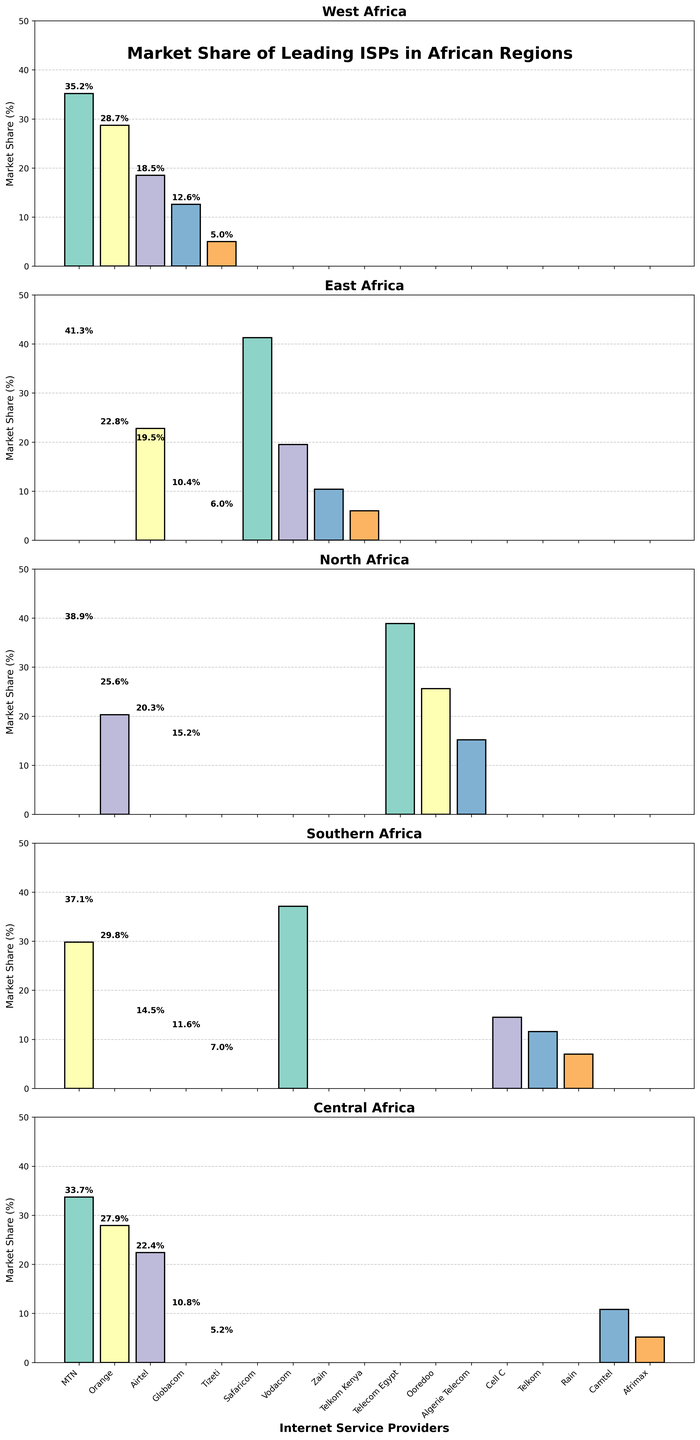Which ISP has the highest market share in West Africa? Look at the bar marked "MTN" in the West Africa section. It is the tallest with a 35.2% share.
Answer: MTN What is the combined market share of MTN and Orange in Central Africa? MTN has a 33.7% share and Orange has a 27.9% share. Adding them together: 33.7% + 27.9% = 61.6%.
Answer: 61.6% In which region does Airtel have the highest market share? Compare the bars for Airtel across all regions. Airtel has the tallest bar in East Africa with a 22.8% share.
Answer: East Africa How does Vodacom's market share in East Africa compare to its share in Southern Africa? Vodacom has a 19.5% share in East Africa and a 37.1% share in Southern Africa. The Southern Africa share is greater.
Answer: Southern Africa Which ISP has the lowest market share in North Africa? Look at the bars in the North Africa section. Algerie Telecom has the shortest bar with a 15.2% share.
Answer: Algerie Telecom What is the market share difference between MTN and Cell C in Southern Africa? MTN has a 29.8% share and Cell C has a 14.5% share. Subtract Cell C's share from MTN's: 29.8% - 14.5% = 15.3%.
Answer: 15.3% Compare the market share of Telkom in East Africa and Southern Africa. Telkom has a 6.0% share in East Africa and an 11.6% share in Southern Africa. The Southern Africa share is higher.
Answer: Southern Africa Which region has the highest market share for a single ISP? Compare the highest bars in each region: MTN (35.2%) in West Africa, Safaricom (41.3%) in East Africa, Telecom Egypt (38.9%) in North Africa, Vodacom (37.1%) in Southern Africa, and MTN (33.7%) in Central Africa. Safaricom in East Africa has the highest.
Answer: East Africa What is the average market share of ISPs in West Africa? Add the market shares of ISPs in West Africa: 35.2% + 28.7% + 18.5% + 12.6% + 5.0% = 100%. The average share is 100% / 5 ISPs = 20%.
Answer: 20% Which regions have Orange as an ISP and what are their market share values? Orange is present in West Africa (28.7%), North Africa (20.3%), and Central Africa (27.9%).
Answer: West Africa (28.7%), North Africa (20.3%), Central Africa (27.9%) 